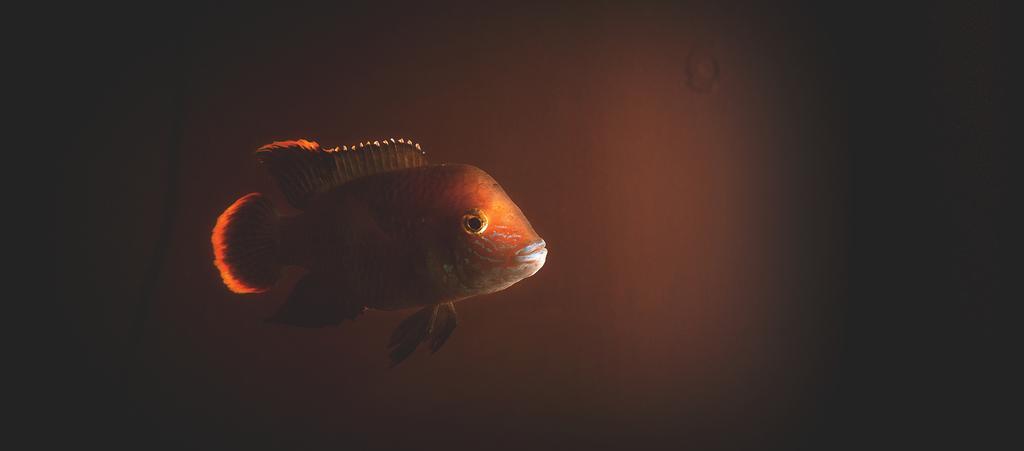Describe this image in one or two sentences. In this image, we can see a fish. It is in orange color. 